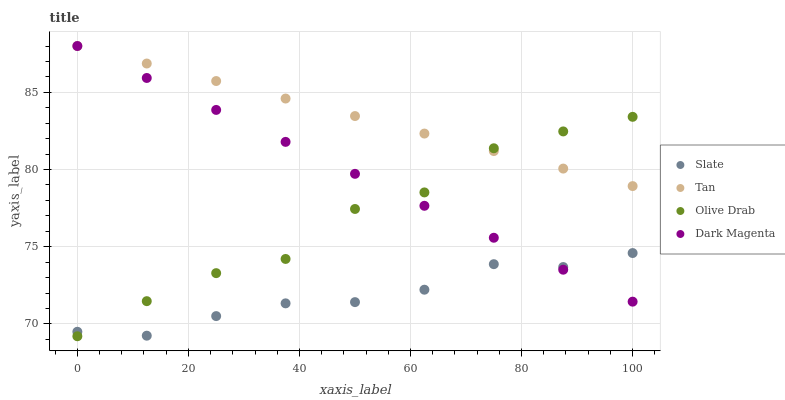Does Slate have the minimum area under the curve?
Answer yes or no. Yes. Does Tan have the maximum area under the curve?
Answer yes or no. Yes. Does Olive Drab have the minimum area under the curve?
Answer yes or no. No. Does Olive Drab have the maximum area under the curve?
Answer yes or no. No. Is Dark Magenta the smoothest?
Answer yes or no. Yes. Is Olive Drab the roughest?
Answer yes or no. Yes. Is Tan the smoothest?
Answer yes or no. No. Is Tan the roughest?
Answer yes or no. No. Does Olive Drab have the lowest value?
Answer yes or no. Yes. Does Tan have the lowest value?
Answer yes or no. No. Does Dark Magenta have the highest value?
Answer yes or no. Yes. Does Olive Drab have the highest value?
Answer yes or no. No. Is Slate less than Tan?
Answer yes or no. Yes. Is Tan greater than Slate?
Answer yes or no. Yes. Does Dark Magenta intersect Tan?
Answer yes or no. Yes. Is Dark Magenta less than Tan?
Answer yes or no. No. Is Dark Magenta greater than Tan?
Answer yes or no. No. Does Slate intersect Tan?
Answer yes or no. No. 